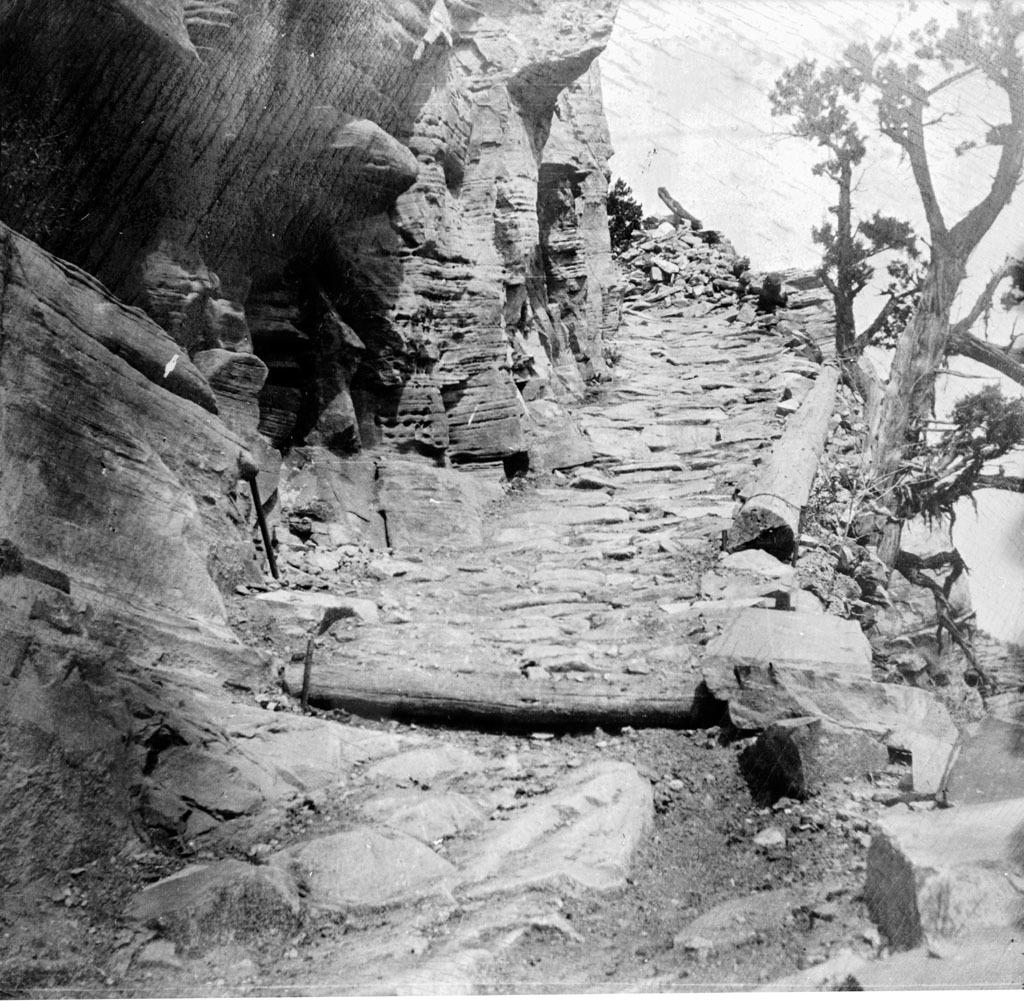What is the color scheme of the image? The image is black and white. What type of natural materials can be seen in the image? There are wooden twigs, rocks, and stones in the image. What type of vegetation is on the right side of the image? There are trees on the right side of the image. What type of natural materials are on the left side of the image? There are rocks on the left side of the image. Can you see any cherries hanging from the trees in the image? There are no cherries present in the image; it only features trees, wooden twigs, rocks, and stones. What type of dinner is being served in the image? There is no dinner or any food present in the image. 